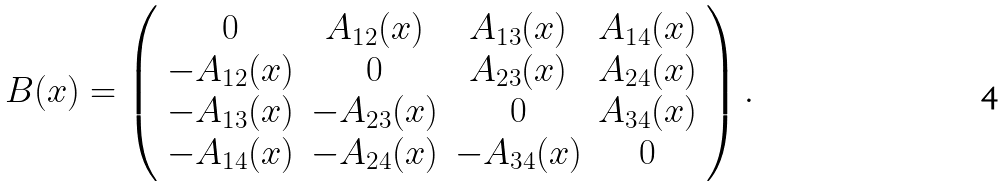<formula> <loc_0><loc_0><loc_500><loc_500>B ( x ) = \left ( \begin{array} { c c c c } 0 & A _ { 1 2 } ( x ) & A _ { 1 3 } ( x ) & A _ { 1 4 } ( x ) \\ - A _ { 1 2 } ( x ) & 0 & A _ { 2 3 } ( x ) & A _ { 2 4 } ( x ) \\ - A _ { 1 3 } ( x ) & - A _ { 2 3 } ( x ) & 0 & A _ { 3 4 } ( x ) \\ - A _ { 1 4 } ( x ) & - A _ { 2 4 } ( x ) & - A _ { 3 4 } ( x ) & 0 \end{array} \right ) . \\</formula> 